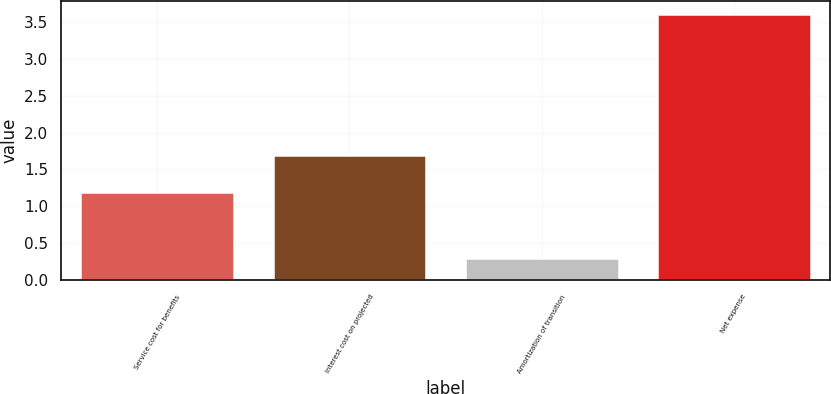Convert chart to OTSL. <chart><loc_0><loc_0><loc_500><loc_500><bar_chart><fcel>Service cost for benefits<fcel>Interest cost on projected<fcel>Amortization of transition<fcel>Net expense<nl><fcel>1.2<fcel>1.7<fcel>0.3<fcel>3.6<nl></chart> 